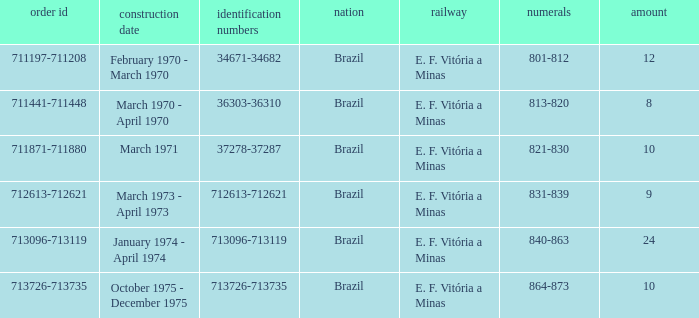The serial numbers 713096-713119 are in which country? Brazil. 